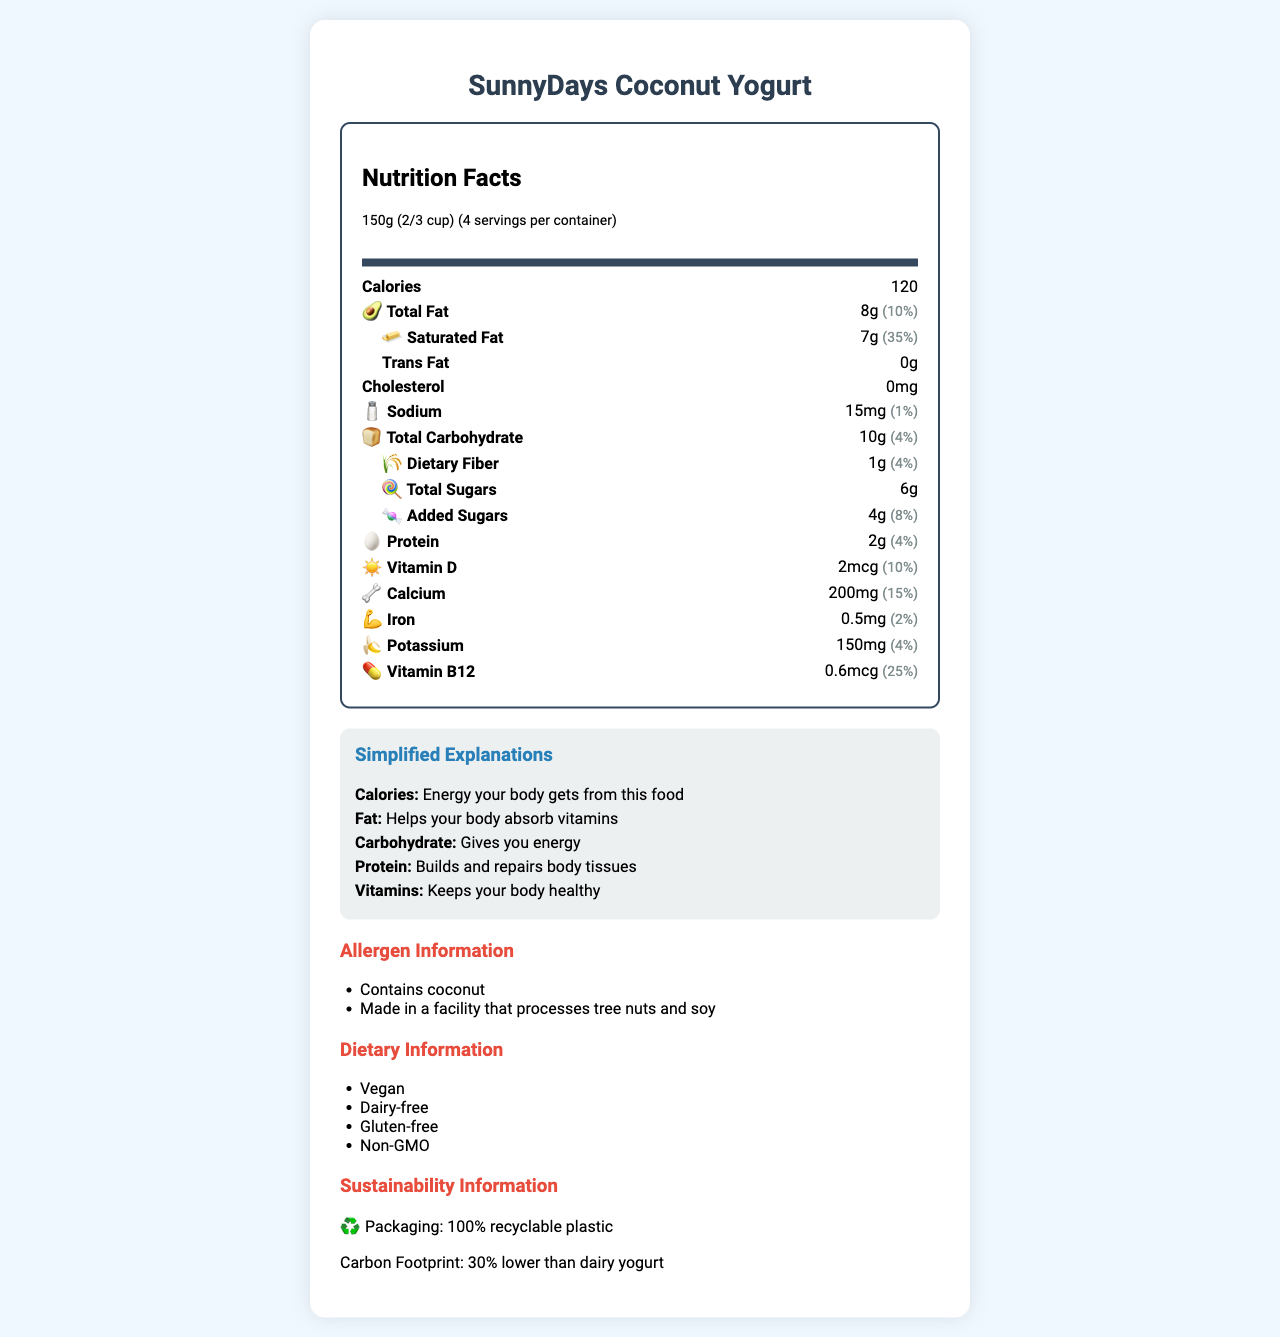what is the serving size of SunnyDays Coconut Yogurt? The serving size is mentioned in the "serving info" section.
Answer: 150g (2/3 cup) how many calories are there per serving? The number of calories per serving is listed as "120" in the nutrient section.
Answer: 120 what is the amount of total fat per serving? The amount of total fat per serving is shown as "8g" in the nutrient section.
Answer: 8g what is the daily value percentage of saturated fat per serving? The daily value percentage for saturated fat is marked as "35%" in the nutrient section.
Answer: 35% how much protein is in one serving of SunnyDays Coconut Yogurt? The protein content per serving is specified as "2g" in the nutrient section.
Answer: 2g which allergen is present in SunnyDays Coconut Yogurt? A. Dairy B. Soy C. Coconut The allergen information section states that the product contains "Coconut".
Answer: C what type of packaging material is used for SunnyDays Coconut Yogurt? A. Glass B. Recyclable Plastic C. Cardboard D. Aluminum The sustainability info indicates "100% recyclable plastic".
Answer: B is SunnyDays Coconut Yogurt suitable for people following a vegan diet? The dietary information confirms that the product is "Vegan".
Answer: Yes does SunnyDays Coconut Yogurt contain any cholesterol? The nutrient section indicates "Cholesterol: 0mg", meaning it contains no cholesterol.
Answer: No describe the accessibility features of the SunnyDays Coconut Yogurt nutrition label. The accessibility features mentioned are specifically listed in the "accessibility features" section.
Answer: The nutrition label of SunnyDays Coconut Yogurt includes features such as high contrast colors, large, easy-to-read font, icon-based nutrient representation, simplified language descriptions, and a QR code for a screen reader-friendly digital version. how many servings are there per container? The number of servings per container is given as "4" in the serving information section.
Answer: 4 what is the purpose of the QR code on the document? The QR code is intended to offer a version that is accessible to screen reader users.
Answer: It provides a screen reader-friendly digital version. list one vitamin present in SunnyDays Coconut Yogurt and its daily value percentage. The nutrient section indicates that Vitamin B12 is present with a daily value percentage of 25%.
Answer: Vitamin B12, 25% Based on the document, what is the main goal of SunnyDays Coconut Yogurt's nutrition label? The entire document focuses on making nutritional information straightforward and accessible by using high contrast, large fonts, icons, and simplified descriptions, while also highlighting allergen, sustainability, and dietary information.
Answer: The main goal is to provide clear, accessible, and simplified nutritional information along with details about allergen, dietary, and sustainability aspects. what is the source of added sugars in SunnyDays Coconut Yogurt? The document does not provide specific details on the source of the added sugars.
Answer: Cannot be determined 